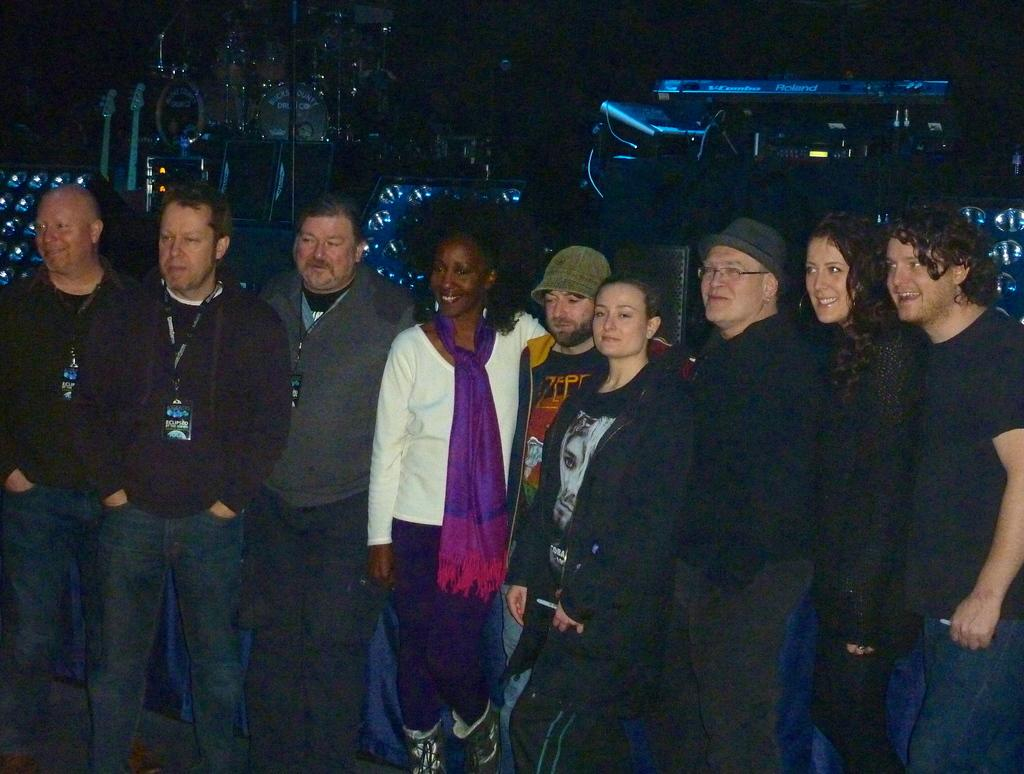What objects can be seen in the image related to light? There are lights in the image. What items are present in the image related to music? There are musical instruments in the image. What can be observed about the people in the middle of the image? There are persons standing in the middle of the image. What are the persons wearing in the image? The persons are wearing clothes. Is there any quicksand present in the image? There is no quicksand present in the image. Can you see a tiger in the image? There is no tiger present in the image. 